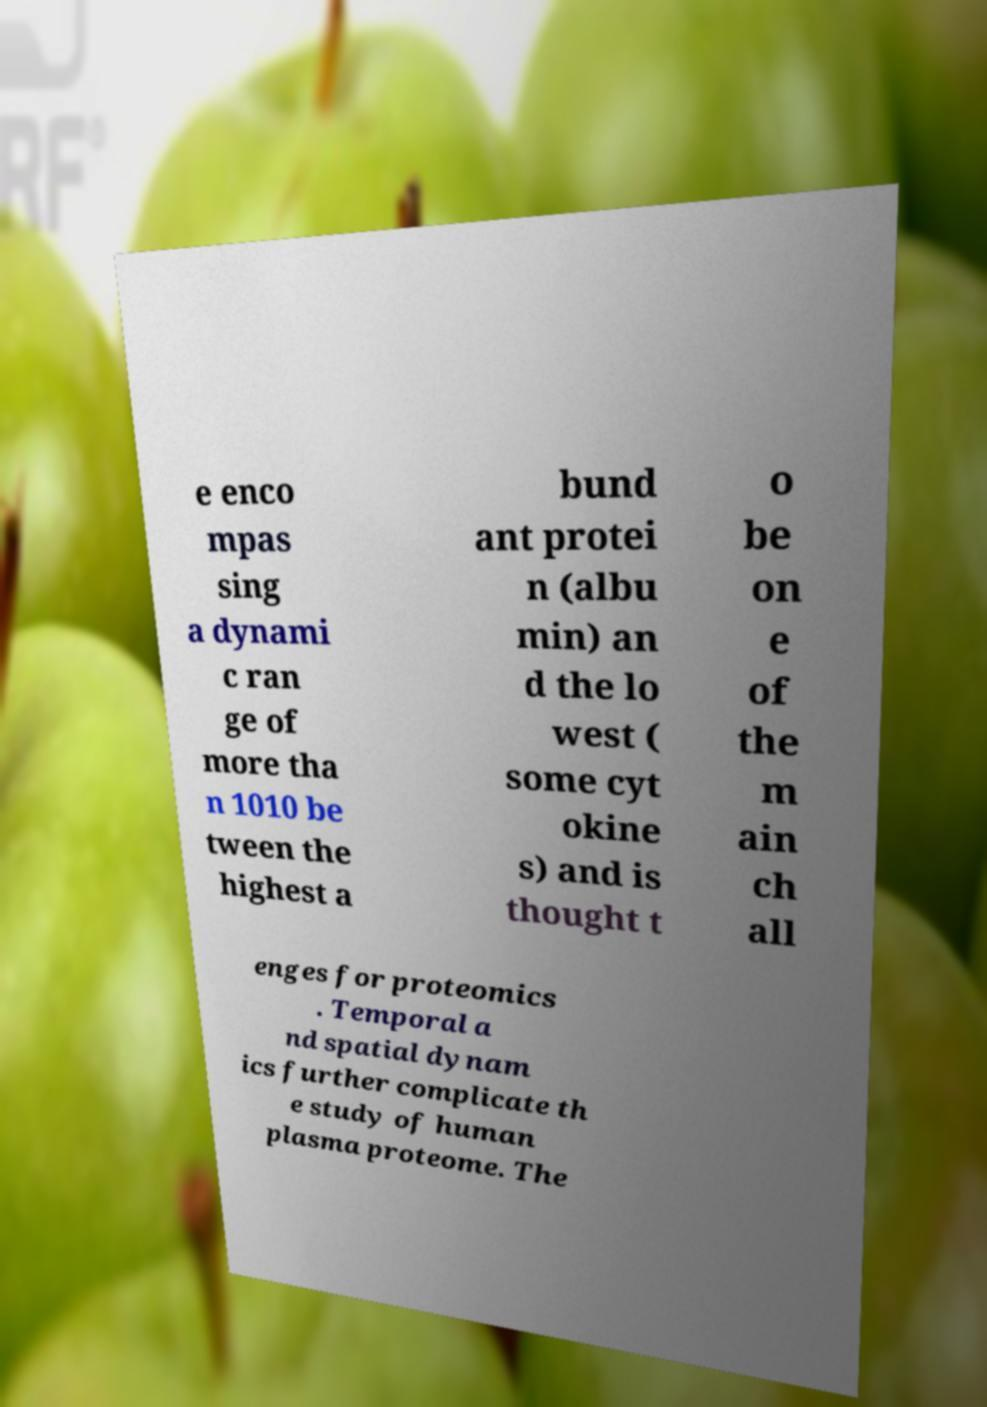For documentation purposes, I need the text within this image transcribed. Could you provide that? e enco mpas sing a dynami c ran ge of more tha n 1010 be tween the highest a bund ant protei n (albu min) an d the lo west ( some cyt okine s) and is thought t o be on e of the m ain ch all enges for proteomics . Temporal a nd spatial dynam ics further complicate th e study of human plasma proteome. The 